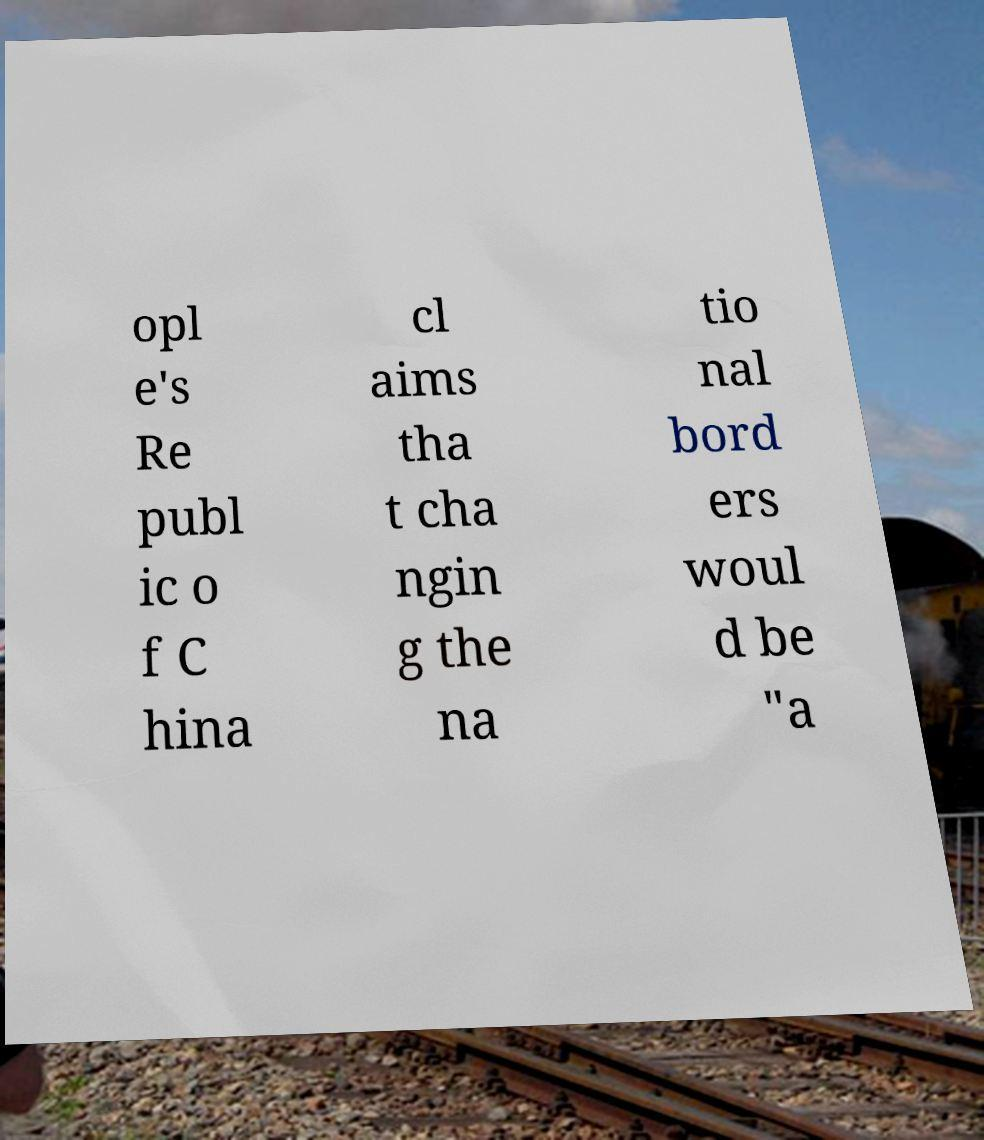Could you extract and type out the text from this image? opl e's Re publ ic o f C hina cl aims tha t cha ngin g the na tio nal bord ers woul d be "a 